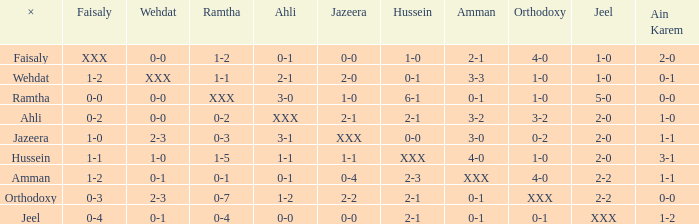What is ahli when ramtha is 0-4? 0-0. 